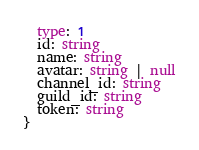Convert code to text. <code><loc_0><loc_0><loc_500><loc_500><_TypeScript_>  type: 1
  id: string
  name: string
  avatar: string | null
  channel_id: string
  guild_id: string
  token: string
}
</code> 